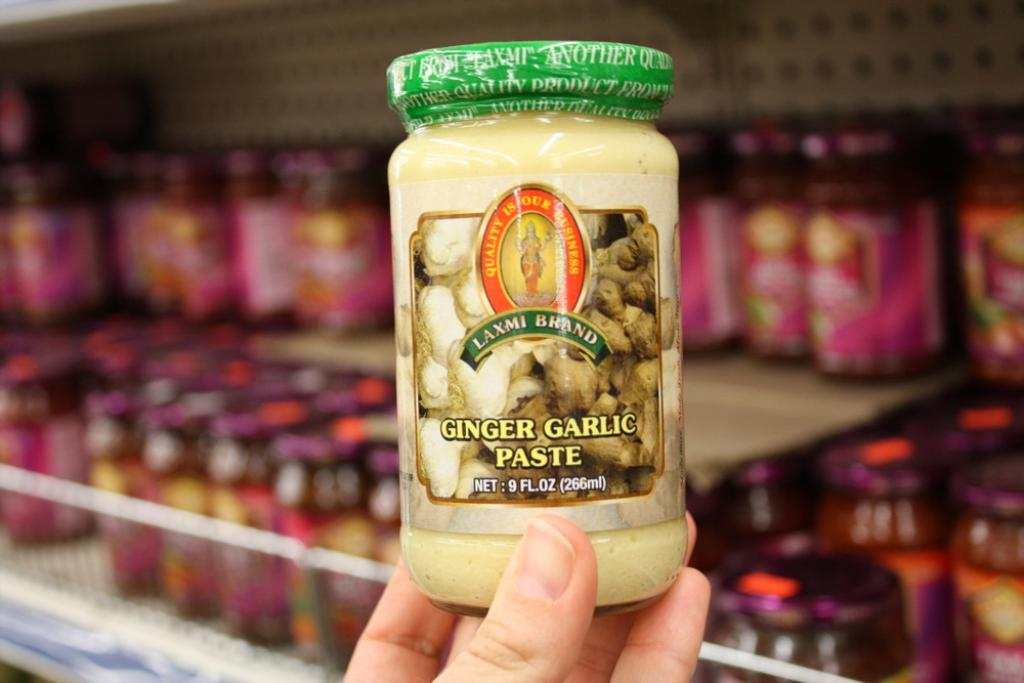What is the main object in the image? There is a garlic paste bottle in the image. Who is holding the bottle? The bottle is held by a person's hand. What can be seen in the background of the image? There are bottles arranged in shelves in the background of the image. Can you see any goldfish swimming in the image? No, there are no goldfish present in the image. Is there a carriage visible in the image? No, there is no carriage present in the image. 